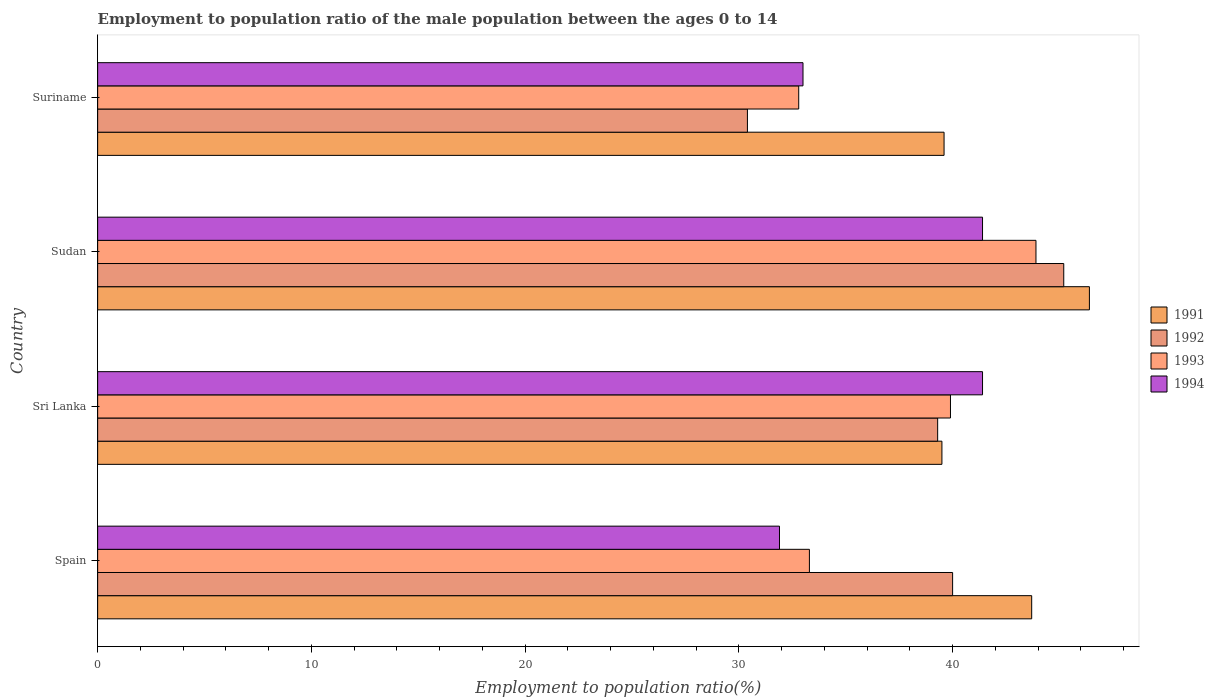How many different coloured bars are there?
Provide a succinct answer. 4. Are the number of bars on each tick of the Y-axis equal?
Ensure brevity in your answer.  Yes. What is the label of the 4th group of bars from the top?
Offer a very short reply. Spain. What is the employment to population ratio in 1994 in Sudan?
Give a very brief answer. 41.4. Across all countries, what is the maximum employment to population ratio in 1994?
Offer a very short reply. 41.4. Across all countries, what is the minimum employment to population ratio in 1991?
Keep it short and to the point. 39.5. In which country was the employment to population ratio in 1993 maximum?
Your response must be concise. Sudan. In which country was the employment to population ratio in 1993 minimum?
Provide a short and direct response. Suriname. What is the total employment to population ratio in 1993 in the graph?
Your response must be concise. 149.9. What is the difference between the employment to population ratio in 1994 in Spain and that in Sri Lanka?
Your answer should be compact. -9.5. What is the difference between the employment to population ratio in 1992 in Suriname and the employment to population ratio in 1993 in Sri Lanka?
Keep it short and to the point. -9.5. What is the average employment to population ratio in 1993 per country?
Ensure brevity in your answer.  37.48. What is the ratio of the employment to population ratio in 1993 in Sri Lanka to that in Suriname?
Provide a short and direct response. 1.22. Is the employment to population ratio in 1991 in Spain less than that in Sudan?
Offer a very short reply. Yes. Is the difference between the employment to population ratio in 1991 in Spain and Suriname greater than the difference between the employment to population ratio in 1994 in Spain and Suriname?
Your answer should be very brief. Yes. What is the difference between the highest and the second highest employment to population ratio in 1994?
Ensure brevity in your answer.  0. What is the difference between the highest and the lowest employment to population ratio in 1994?
Offer a terse response. 9.5. In how many countries, is the employment to population ratio in 1993 greater than the average employment to population ratio in 1993 taken over all countries?
Offer a terse response. 2. Is the sum of the employment to population ratio in 1992 in Spain and Suriname greater than the maximum employment to population ratio in 1994 across all countries?
Keep it short and to the point. Yes. Is it the case that in every country, the sum of the employment to population ratio in 1993 and employment to population ratio in 1994 is greater than the sum of employment to population ratio in 1992 and employment to population ratio in 1991?
Provide a succinct answer. Yes. What does the 4th bar from the top in Sri Lanka represents?
Make the answer very short. 1991. How many bars are there?
Give a very brief answer. 16. Are all the bars in the graph horizontal?
Provide a succinct answer. Yes. How many countries are there in the graph?
Ensure brevity in your answer.  4. What is the difference between two consecutive major ticks on the X-axis?
Provide a succinct answer. 10. How many legend labels are there?
Ensure brevity in your answer.  4. What is the title of the graph?
Your response must be concise. Employment to population ratio of the male population between the ages 0 to 14. What is the label or title of the Y-axis?
Keep it short and to the point. Country. What is the Employment to population ratio(%) in 1991 in Spain?
Ensure brevity in your answer.  43.7. What is the Employment to population ratio(%) in 1993 in Spain?
Offer a very short reply. 33.3. What is the Employment to population ratio(%) in 1994 in Spain?
Offer a very short reply. 31.9. What is the Employment to population ratio(%) of 1991 in Sri Lanka?
Give a very brief answer. 39.5. What is the Employment to population ratio(%) in 1992 in Sri Lanka?
Your response must be concise. 39.3. What is the Employment to population ratio(%) of 1993 in Sri Lanka?
Your answer should be very brief. 39.9. What is the Employment to population ratio(%) in 1994 in Sri Lanka?
Your answer should be very brief. 41.4. What is the Employment to population ratio(%) in 1991 in Sudan?
Offer a terse response. 46.4. What is the Employment to population ratio(%) of 1992 in Sudan?
Keep it short and to the point. 45.2. What is the Employment to population ratio(%) of 1993 in Sudan?
Ensure brevity in your answer.  43.9. What is the Employment to population ratio(%) in 1994 in Sudan?
Keep it short and to the point. 41.4. What is the Employment to population ratio(%) of 1991 in Suriname?
Your response must be concise. 39.6. What is the Employment to population ratio(%) in 1992 in Suriname?
Offer a very short reply. 30.4. What is the Employment to population ratio(%) of 1993 in Suriname?
Your response must be concise. 32.8. Across all countries, what is the maximum Employment to population ratio(%) in 1991?
Ensure brevity in your answer.  46.4. Across all countries, what is the maximum Employment to population ratio(%) in 1992?
Your answer should be compact. 45.2. Across all countries, what is the maximum Employment to population ratio(%) of 1993?
Your answer should be compact. 43.9. Across all countries, what is the maximum Employment to population ratio(%) of 1994?
Provide a succinct answer. 41.4. Across all countries, what is the minimum Employment to population ratio(%) in 1991?
Offer a terse response. 39.5. Across all countries, what is the minimum Employment to population ratio(%) of 1992?
Your response must be concise. 30.4. Across all countries, what is the minimum Employment to population ratio(%) in 1993?
Ensure brevity in your answer.  32.8. Across all countries, what is the minimum Employment to population ratio(%) of 1994?
Offer a terse response. 31.9. What is the total Employment to population ratio(%) in 1991 in the graph?
Keep it short and to the point. 169.2. What is the total Employment to population ratio(%) in 1992 in the graph?
Offer a very short reply. 154.9. What is the total Employment to population ratio(%) of 1993 in the graph?
Provide a succinct answer. 149.9. What is the total Employment to population ratio(%) of 1994 in the graph?
Ensure brevity in your answer.  147.7. What is the difference between the Employment to population ratio(%) in 1994 in Spain and that in Sri Lanka?
Your answer should be compact. -9.5. What is the difference between the Employment to population ratio(%) of 1991 in Spain and that in Sudan?
Ensure brevity in your answer.  -2.7. What is the difference between the Employment to population ratio(%) of 1993 in Spain and that in Sudan?
Your response must be concise. -10.6. What is the difference between the Employment to population ratio(%) in 1991 in Spain and that in Suriname?
Ensure brevity in your answer.  4.1. What is the difference between the Employment to population ratio(%) in 1994 in Spain and that in Suriname?
Provide a succinct answer. -1.1. What is the difference between the Employment to population ratio(%) in 1993 in Sri Lanka and that in Sudan?
Your response must be concise. -4. What is the difference between the Employment to population ratio(%) in 1992 in Sri Lanka and that in Suriname?
Give a very brief answer. 8.9. What is the difference between the Employment to population ratio(%) of 1993 in Sri Lanka and that in Suriname?
Your answer should be very brief. 7.1. What is the difference between the Employment to population ratio(%) of 1994 in Sri Lanka and that in Suriname?
Offer a very short reply. 8.4. What is the difference between the Employment to population ratio(%) in 1991 in Sudan and that in Suriname?
Make the answer very short. 6.8. What is the difference between the Employment to population ratio(%) of 1993 in Sudan and that in Suriname?
Offer a very short reply. 11.1. What is the difference between the Employment to population ratio(%) of 1994 in Sudan and that in Suriname?
Ensure brevity in your answer.  8.4. What is the difference between the Employment to population ratio(%) in 1991 in Spain and the Employment to population ratio(%) in 1992 in Sri Lanka?
Ensure brevity in your answer.  4.4. What is the difference between the Employment to population ratio(%) of 1991 in Spain and the Employment to population ratio(%) of 1994 in Sri Lanka?
Provide a succinct answer. 2.3. What is the difference between the Employment to population ratio(%) of 1992 in Spain and the Employment to population ratio(%) of 1993 in Sri Lanka?
Offer a terse response. 0.1. What is the difference between the Employment to population ratio(%) of 1993 in Spain and the Employment to population ratio(%) of 1994 in Sri Lanka?
Make the answer very short. -8.1. What is the difference between the Employment to population ratio(%) in 1991 in Spain and the Employment to population ratio(%) in 1992 in Sudan?
Offer a terse response. -1.5. What is the difference between the Employment to population ratio(%) in 1993 in Spain and the Employment to population ratio(%) in 1994 in Sudan?
Your answer should be very brief. -8.1. What is the difference between the Employment to population ratio(%) in 1991 in Spain and the Employment to population ratio(%) in 1993 in Suriname?
Provide a succinct answer. 10.9. What is the difference between the Employment to population ratio(%) of 1991 in Spain and the Employment to population ratio(%) of 1994 in Suriname?
Ensure brevity in your answer.  10.7. What is the difference between the Employment to population ratio(%) in 1991 in Sri Lanka and the Employment to population ratio(%) in 1992 in Sudan?
Your response must be concise. -5.7. What is the difference between the Employment to population ratio(%) in 1991 in Sri Lanka and the Employment to population ratio(%) in 1993 in Sudan?
Your response must be concise. -4.4. What is the difference between the Employment to population ratio(%) in 1991 in Sri Lanka and the Employment to population ratio(%) in 1994 in Sudan?
Provide a succinct answer. -1.9. What is the difference between the Employment to population ratio(%) in 1992 in Sri Lanka and the Employment to population ratio(%) in 1994 in Sudan?
Keep it short and to the point. -2.1. What is the difference between the Employment to population ratio(%) in 1991 in Sri Lanka and the Employment to population ratio(%) in 1992 in Suriname?
Ensure brevity in your answer.  9.1. What is the difference between the Employment to population ratio(%) in 1991 in Sri Lanka and the Employment to population ratio(%) in 1994 in Suriname?
Your answer should be very brief. 6.5. What is the difference between the Employment to population ratio(%) of 1992 in Sri Lanka and the Employment to population ratio(%) of 1994 in Suriname?
Offer a terse response. 6.3. What is the difference between the Employment to population ratio(%) of 1991 in Sudan and the Employment to population ratio(%) of 1992 in Suriname?
Offer a very short reply. 16. What is the difference between the Employment to population ratio(%) of 1991 in Sudan and the Employment to population ratio(%) of 1993 in Suriname?
Offer a terse response. 13.6. What is the difference between the Employment to population ratio(%) of 1991 in Sudan and the Employment to population ratio(%) of 1994 in Suriname?
Make the answer very short. 13.4. What is the difference between the Employment to population ratio(%) in 1992 in Sudan and the Employment to population ratio(%) in 1994 in Suriname?
Keep it short and to the point. 12.2. What is the average Employment to population ratio(%) in 1991 per country?
Your response must be concise. 42.3. What is the average Employment to population ratio(%) in 1992 per country?
Make the answer very short. 38.73. What is the average Employment to population ratio(%) of 1993 per country?
Your answer should be compact. 37.48. What is the average Employment to population ratio(%) of 1994 per country?
Provide a short and direct response. 36.92. What is the difference between the Employment to population ratio(%) of 1991 and Employment to population ratio(%) of 1992 in Spain?
Keep it short and to the point. 3.7. What is the difference between the Employment to population ratio(%) in 1991 and Employment to population ratio(%) in 1993 in Spain?
Provide a succinct answer. 10.4. What is the difference between the Employment to population ratio(%) of 1992 and Employment to population ratio(%) of 1994 in Spain?
Offer a terse response. 8.1. What is the difference between the Employment to population ratio(%) in 1991 and Employment to population ratio(%) in 1992 in Sri Lanka?
Provide a short and direct response. 0.2. What is the difference between the Employment to population ratio(%) of 1991 and Employment to population ratio(%) of 1994 in Sri Lanka?
Make the answer very short. -1.9. What is the difference between the Employment to population ratio(%) of 1991 and Employment to population ratio(%) of 1994 in Sudan?
Offer a terse response. 5. What is the difference between the Employment to population ratio(%) of 1993 and Employment to population ratio(%) of 1994 in Sudan?
Your answer should be very brief. 2.5. What is the difference between the Employment to population ratio(%) in 1992 and Employment to population ratio(%) in 1993 in Suriname?
Make the answer very short. -2.4. What is the difference between the Employment to population ratio(%) in 1992 and Employment to population ratio(%) in 1994 in Suriname?
Your response must be concise. -2.6. What is the ratio of the Employment to population ratio(%) of 1991 in Spain to that in Sri Lanka?
Offer a terse response. 1.11. What is the ratio of the Employment to population ratio(%) in 1992 in Spain to that in Sri Lanka?
Your answer should be compact. 1.02. What is the ratio of the Employment to population ratio(%) of 1993 in Spain to that in Sri Lanka?
Your response must be concise. 0.83. What is the ratio of the Employment to population ratio(%) of 1994 in Spain to that in Sri Lanka?
Offer a very short reply. 0.77. What is the ratio of the Employment to population ratio(%) of 1991 in Spain to that in Sudan?
Your response must be concise. 0.94. What is the ratio of the Employment to population ratio(%) of 1992 in Spain to that in Sudan?
Your answer should be compact. 0.89. What is the ratio of the Employment to population ratio(%) of 1993 in Spain to that in Sudan?
Your answer should be compact. 0.76. What is the ratio of the Employment to population ratio(%) in 1994 in Spain to that in Sudan?
Offer a very short reply. 0.77. What is the ratio of the Employment to population ratio(%) in 1991 in Spain to that in Suriname?
Keep it short and to the point. 1.1. What is the ratio of the Employment to population ratio(%) of 1992 in Spain to that in Suriname?
Offer a terse response. 1.32. What is the ratio of the Employment to population ratio(%) in 1993 in Spain to that in Suriname?
Your response must be concise. 1.02. What is the ratio of the Employment to population ratio(%) of 1994 in Spain to that in Suriname?
Ensure brevity in your answer.  0.97. What is the ratio of the Employment to population ratio(%) in 1991 in Sri Lanka to that in Sudan?
Keep it short and to the point. 0.85. What is the ratio of the Employment to population ratio(%) in 1992 in Sri Lanka to that in Sudan?
Your response must be concise. 0.87. What is the ratio of the Employment to population ratio(%) of 1993 in Sri Lanka to that in Sudan?
Your answer should be compact. 0.91. What is the ratio of the Employment to population ratio(%) of 1994 in Sri Lanka to that in Sudan?
Keep it short and to the point. 1. What is the ratio of the Employment to population ratio(%) in 1992 in Sri Lanka to that in Suriname?
Give a very brief answer. 1.29. What is the ratio of the Employment to population ratio(%) of 1993 in Sri Lanka to that in Suriname?
Your response must be concise. 1.22. What is the ratio of the Employment to population ratio(%) in 1994 in Sri Lanka to that in Suriname?
Provide a succinct answer. 1.25. What is the ratio of the Employment to population ratio(%) in 1991 in Sudan to that in Suriname?
Offer a terse response. 1.17. What is the ratio of the Employment to population ratio(%) of 1992 in Sudan to that in Suriname?
Offer a terse response. 1.49. What is the ratio of the Employment to population ratio(%) of 1993 in Sudan to that in Suriname?
Your response must be concise. 1.34. What is the ratio of the Employment to population ratio(%) in 1994 in Sudan to that in Suriname?
Make the answer very short. 1.25. What is the difference between the highest and the second highest Employment to population ratio(%) in 1992?
Keep it short and to the point. 5.2. What is the difference between the highest and the lowest Employment to population ratio(%) in 1991?
Make the answer very short. 6.9. What is the difference between the highest and the lowest Employment to population ratio(%) of 1994?
Give a very brief answer. 9.5. 